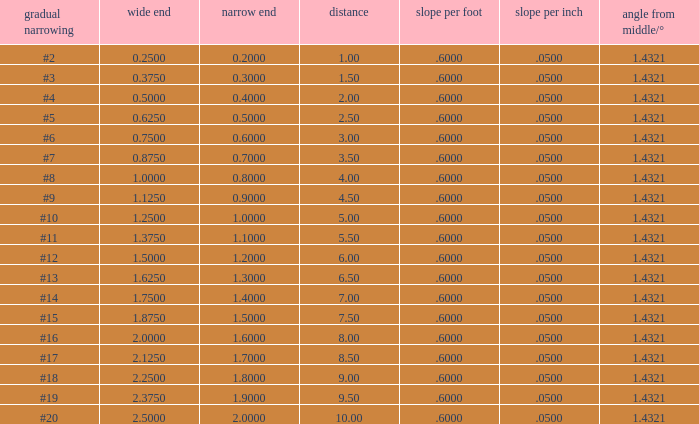Which Large end has a Taper/ft smaller than 0.6000000000000001? 19.0. 